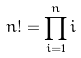Convert formula to latex. <formula><loc_0><loc_0><loc_500><loc_500>n ! = \prod _ { i = 1 } ^ { n } i</formula> 